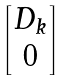Convert formula to latex. <formula><loc_0><loc_0><loc_500><loc_500>\begin{bmatrix} { D } _ { k } \\ { 0 } \end{bmatrix}</formula> 